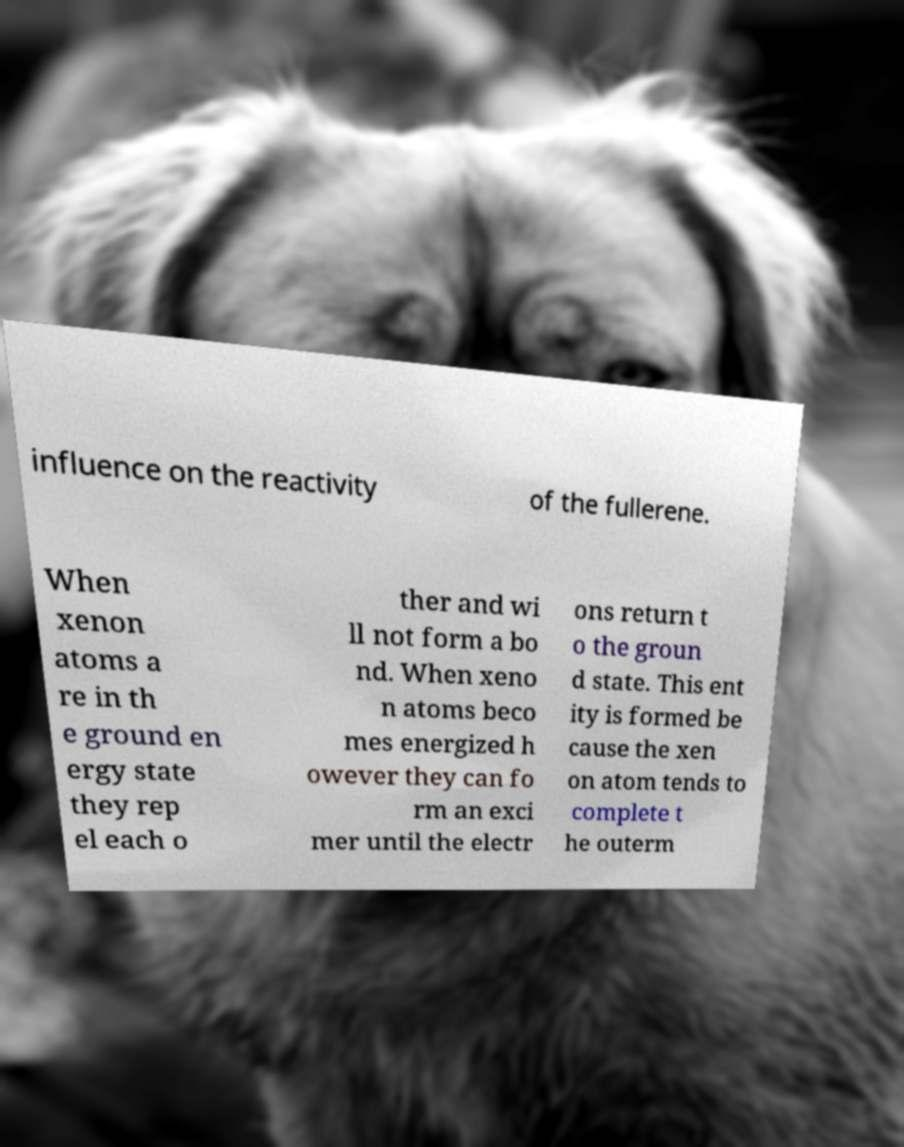Could you extract and type out the text from this image? influence on the reactivity of the fullerene. When xenon atoms a re in th e ground en ergy state they rep el each o ther and wi ll not form a bo nd. When xeno n atoms beco mes energized h owever they can fo rm an exci mer until the electr ons return t o the groun d state. This ent ity is formed be cause the xen on atom tends to complete t he outerm 